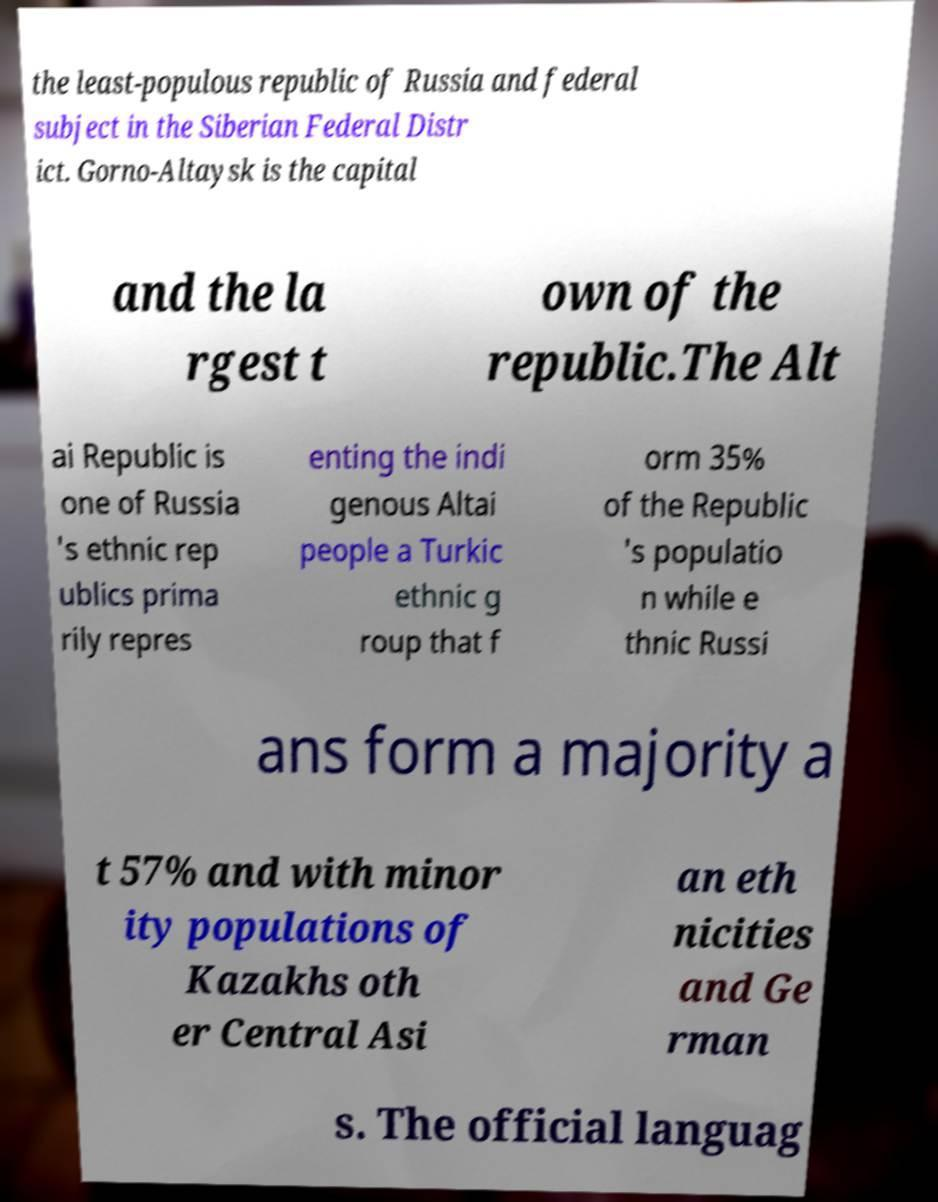Please identify and transcribe the text found in this image. the least-populous republic of Russia and federal subject in the Siberian Federal Distr ict. Gorno-Altaysk is the capital and the la rgest t own of the republic.The Alt ai Republic is one of Russia 's ethnic rep ublics prima rily repres enting the indi genous Altai people a Turkic ethnic g roup that f orm 35% of the Republic 's populatio n while e thnic Russi ans form a majority a t 57% and with minor ity populations of Kazakhs oth er Central Asi an eth nicities and Ge rman s. The official languag 